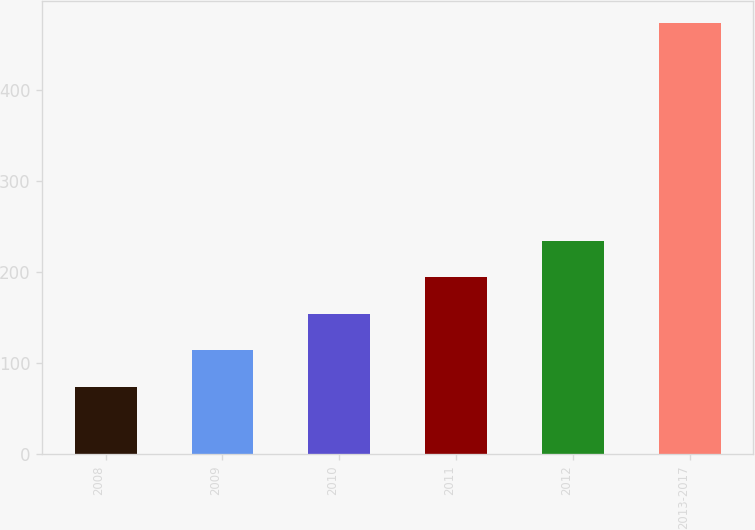Convert chart. <chart><loc_0><loc_0><loc_500><loc_500><bar_chart><fcel>2008<fcel>2009<fcel>2010<fcel>2011<fcel>2012<fcel>2013-2017<nl><fcel>74<fcel>114<fcel>154<fcel>194<fcel>234<fcel>474<nl></chart> 